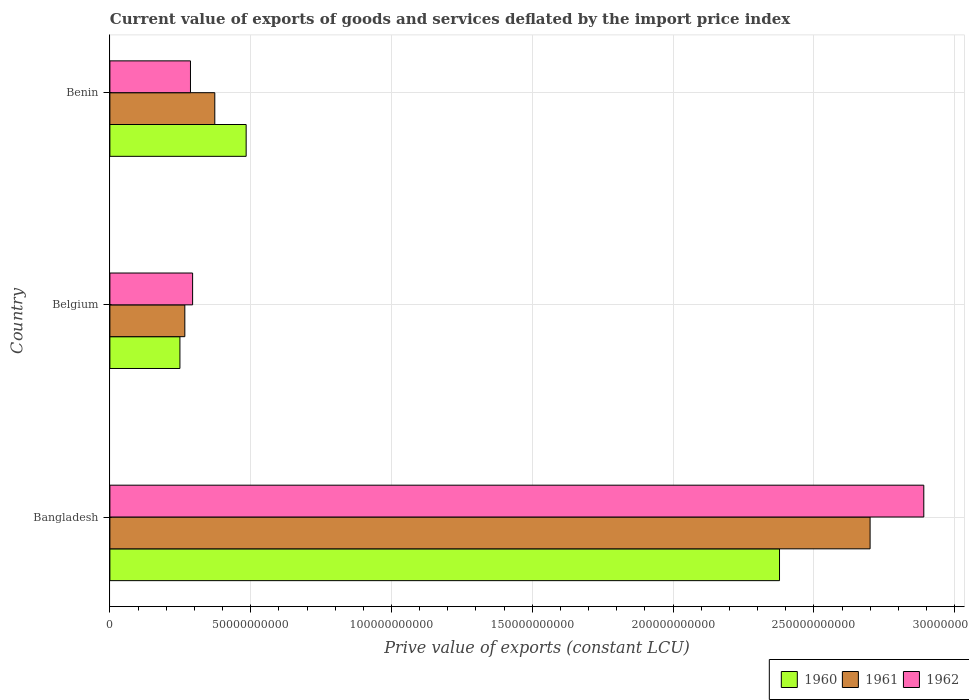How many different coloured bars are there?
Give a very brief answer. 3. How many groups of bars are there?
Your answer should be very brief. 3. Are the number of bars per tick equal to the number of legend labels?
Your answer should be compact. Yes. Are the number of bars on each tick of the Y-axis equal?
Provide a short and direct response. Yes. In how many cases, is the number of bars for a given country not equal to the number of legend labels?
Keep it short and to the point. 0. What is the prive value of exports in 1960 in Benin?
Make the answer very short. 4.84e+1. Across all countries, what is the maximum prive value of exports in 1960?
Offer a very short reply. 2.38e+11. Across all countries, what is the minimum prive value of exports in 1962?
Your response must be concise. 2.86e+1. In which country was the prive value of exports in 1962 minimum?
Offer a very short reply. Benin. What is the total prive value of exports in 1961 in the graph?
Your response must be concise. 3.34e+11. What is the difference between the prive value of exports in 1961 in Bangladesh and that in Belgium?
Provide a short and direct response. 2.43e+11. What is the difference between the prive value of exports in 1962 in Bangladesh and the prive value of exports in 1960 in Belgium?
Your answer should be compact. 2.64e+11. What is the average prive value of exports in 1961 per country?
Give a very brief answer. 1.11e+11. What is the difference between the prive value of exports in 1962 and prive value of exports in 1960 in Benin?
Make the answer very short. -1.98e+1. What is the ratio of the prive value of exports in 1960 in Belgium to that in Benin?
Provide a succinct answer. 0.51. Is the difference between the prive value of exports in 1962 in Bangladesh and Benin greater than the difference between the prive value of exports in 1960 in Bangladesh and Benin?
Your response must be concise. Yes. What is the difference between the highest and the second highest prive value of exports in 1962?
Provide a short and direct response. 2.60e+11. What is the difference between the highest and the lowest prive value of exports in 1962?
Offer a terse response. 2.60e+11. Is the sum of the prive value of exports in 1962 in Belgium and Benin greater than the maximum prive value of exports in 1960 across all countries?
Offer a very short reply. No. What does the 3rd bar from the top in Benin represents?
Ensure brevity in your answer.  1960. What does the 1st bar from the bottom in Belgium represents?
Make the answer very short. 1960. How many bars are there?
Give a very brief answer. 9. Are all the bars in the graph horizontal?
Make the answer very short. Yes. How many countries are there in the graph?
Ensure brevity in your answer.  3. Are the values on the major ticks of X-axis written in scientific E-notation?
Make the answer very short. No. Does the graph contain grids?
Ensure brevity in your answer.  Yes. How are the legend labels stacked?
Offer a very short reply. Horizontal. What is the title of the graph?
Ensure brevity in your answer.  Current value of exports of goods and services deflated by the import price index. What is the label or title of the X-axis?
Your answer should be compact. Prive value of exports (constant LCU). What is the label or title of the Y-axis?
Your response must be concise. Country. What is the Prive value of exports (constant LCU) in 1960 in Bangladesh?
Offer a very short reply. 2.38e+11. What is the Prive value of exports (constant LCU) of 1961 in Bangladesh?
Make the answer very short. 2.70e+11. What is the Prive value of exports (constant LCU) in 1962 in Bangladesh?
Your answer should be very brief. 2.89e+11. What is the Prive value of exports (constant LCU) of 1960 in Belgium?
Keep it short and to the point. 2.49e+1. What is the Prive value of exports (constant LCU) of 1961 in Belgium?
Offer a very short reply. 2.66e+1. What is the Prive value of exports (constant LCU) in 1962 in Belgium?
Ensure brevity in your answer.  2.94e+1. What is the Prive value of exports (constant LCU) of 1960 in Benin?
Keep it short and to the point. 4.84e+1. What is the Prive value of exports (constant LCU) of 1961 in Benin?
Your answer should be very brief. 3.73e+1. What is the Prive value of exports (constant LCU) of 1962 in Benin?
Provide a succinct answer. 2.86e+1. Across all countries, what is the maximum Prive value of exports (constant LCU) in 1960?
Your answer should be very brief. 2.38e+11. Across all countries, what is the maximum Prive value of exports (constant LCU) in 1961?
Your answer should be very brief. 2.70e+11. Across all countries, what is the maximum Prive value of exports (constant LCU) in 1962?
Offer a terse response. 2.89e+11. Across all countries, what is the minimum Prive value of exports (constant LCU) of 1960?
Offer a very short reply. 2.49e+1. Across all countries, what is the minimum Prive value of exports (constant LCU) of 1961?
Make the answer very short. 2.66e+1. Across all countries, what is the minimum Prive value of exports (constant LCU) in 1962?
Offer a terse response. 2.86e+1. What is the total Prive value of exports (constant LCU) in 1960 in the graph?
Offer a very short reply. 3.11e+11. What is the total Prive value of exports (constant LCU) in 1961 in the graph?
Provide a short and direct response. 3.34e+11. What is the total Prive value of exports (constant LCU) in 1962 in the graph?
Keep it short and to the point. 3.47e+11. What is the difference between the Prive value of exports (constant LCU) of 1960 in Bangladesh and that in Belgium?
Provide a short and direct response. 2.13e+11. What is the difference between the Prive value of exports (constant LCU) of 1961 in Bangladesh and that in Belgium?
Provide a short and direct response. 2.43e+11. What is the difference between the Prive value of exports (constant LCU) of 1962 in Bangladesh and that in Belgium?
Make the answer very short. 2.60e+11. What is the difference between the Prive value of exports (constant LCU) in 1960 in Bangladesh and that in Benin?
Offer a very short reply. 1.89e+11. What is the difference between the Prive value of exports (constant LCU) of 1961 in Bangladesh and that in Benin?
Make the answer very short. 2.33e+11. What is the difference between the Prive value of exports (constant LCU) in 1962 in Bangladesh and that in Benin?
Give a very brief answer. 2.60e+11. What is the difference between the Prive value of exports (constant LCU) of 1960 in Belgium and that in Benin?
Your answer should be very brief. -2.35e+1. What is the difference between the Prive value of exports (constant LCU) in 1961 in Belgium and that in Benin?
Make the answer very short. -1.06e+1. What is the difference between the Prive value of exports (constant LCU) of 1962 in Belgium and that in Benin?
Your answer should be very brief. 7.58e+08. What is the difference between the Prive value of exports (constant LCU) in 1960 in Bangladesh and the Prive value of exports (constant LCU) in 1961 in Belgium?
Your answer should be compact. 2.11e+11. What is the difference between the Prive value of exports (constant LCU) of 1960 in Bangladesh and the Prive value of exports (constant LCU) of 1962 in Belgium?
Your answer should be compact. 2.08e+11. What is the difference between the Prive value of exports (constant LCU) of 1961 in Bangladesh and the Prive value of exports (constant LCU) of 1962 in Belgium?
Your response must be concise. 2.41e+11. What is the difference between the Prive value of exports (constant LCU) in 1960 in Bangladesh and the Prive value of exports (constant LCU) in 1961 in Benin?
Provide a succinct answer. 2.01e+11. What is the difference between the Prive value of exports (constant LCU) in 1960 in Bangladesh and the Prive value of exports (constant LCU) in 1962 in Benin?
Offer a very short reply. 2.09e+11. What is the difference between the Prive value of exports (constant LCU) of 1961 in Bangladesh and the Prive value of exports (constant LCU) of 1962 in Benin?
Your response must be concise. 2.41e+11. What is the difference between the Prive value of exports (constant LCU) of 1960 in Belgium and the Prive value of exports (constant LCU) of 1961 in Benin?
Ensure brevity in your answer.  -1.24e+1. What is the difference between the Prive value of exports (constant LCU) of 1960 in Belgium and the Prive value of exports (constant LCU) of 1962 in Benin?
Ensure brevity in your answer.  -3.75e+09. What is the difference between the Prive value of exports (constant LCU) in 1961 in Belgium and the Prive value of exports (constant LCU) in 1962 in Benin?
Provide a short and direct response. -2.00e+09. What is the average Prive value of exports (constant LCU) in 1960 per country?
Your response must be concise. 1.04e+11. What is the average Prive value of exports (constant LCU) of 1961 per country?
Your response must be concise. 1.11e+11. What is the average Prive value of exports (constant LCU) of 1962 per country?
Provide a succinct answer. 1.16e+11. What is the difference between the Prive value of exports (constant LCU) of 1960 and Prive value of exports (constant LCU) of 1961 in Bangladesh?
Keep it short and to the point. -3.22e+1. What is the difference between the Prive value of exports (constant LCU) of 1960 and Prive value of exports (constant LCU) of 1962 in Bangladesh?
Provide a succinct answer. -5.12e+1. What is the difference between the Prive value of exports (constant LCU) of 1961 and Prive value of exports (constant LCU) of 1962 in Bangladesh?
Offer a terse response. -1.91e+1. What is the difference between the Prive value of exports (constant LCU) in 1960 and Prive value of exports (constant LCU) in 1961 in Belgium?
Your answer should be compact. -1.74e+09. What is the difference between the Prive value of exports (constant LCU) of 1960 and Prive value of exports (constant LCU) of 1962 in Belgium?
Your response must be concise. -4.50e+09. What is the difference between the Prive value of exports (constant LCU) of 1961 and Prive value of exports (constant LCU) of 1962 in Belgium?
Provide a succinct answer. -2.76e+09. What is the difference between the Prive value of exports (constant LCU) in 1960 and Prive value of exports (constant LCU) in 1961 in Benin?
Your answer should be compact. 1.11e+1. What is the difference between the Prive value of exports (constant LCU) of 1960 and Prive value of exports (constant LCU) of 1962 in Benin?
Your answer should be very brief. 1.98e+1. What is the difference between the Prive value of exports (constant LCU) of 1961 and Prive value of exports (constant LCU) of 1962 in Benin?
Ensure brevity in your answer.  8.64e+09. What is the ratio of the Prive value of exports (constant LCU) in 1960 in Bangladesh to that in Belgium?
Your response must be concise. 9.56. What is the ratio of the Prive value of exports (constant LCU) of 1961 in Bangladesh to that in Belgium?
Offer a very short reply. 10.14. What is the ratio of the Prive value of exports (constant LCU) of 1962 in Bangladesh to that in Belgium?
Offer a very short reply. 9.84. What is the ratio of the Prive value of exports (constant LCU) in 1960 in Bangladesh to that in Benin?
Provide a short and direct response. 4.91. What is the ratio of the Prive value of exports (constant LCU) in 1961 in Bangladesh to that in Benin?
Provide a succinct answer. 7.25. What is the ratio of the Prive value of exports (constant LCU) of 1962 in Bangladesh to that in Benin?
Your response must be concise. 10.1. What is the ratio of the Prive value of exports (constant LCU) in 1960 in Belgium to that in Benin?
Offer a terse response. 0.51. What is the ratio of the Prive value of exports (constant LCU) in 1961 in Belgium to that in Benin?
Your answer should be very brief. 0.71. What is the ratio of the Prive value of exports (constant LCU) of 1962 in Belgium to that in Benin?
Offer a very short reply. 1.03. What is the difference between the highest and the second highest Prive value of exports (constant LCU) of 1960?
Provide a succinct answer. 1.89e+11. What is the difference between the highest and the second highest Prive value of exports (constant LCU) of 1961?
Your answer should be very brief. 2.33e+11. What is the difference between the highest and the second highest Prive value of exports (constant LCU) of 1962?
Keep it short and to the point. 2.60e+11. What is the difference between the highest and the lowest Prive value of exports (constant LCU) in 1960?
Your answer should be very brief. 2.13e+11. What is the difference between the highest and the lowest Prive value of exports (constant LCU) of 1961?
Your answer should be compact. 2.43e+11. What is the difference between the highest and the lowest Prive value of exports (constant LCU) of 1962?
Make the answer very short. 2.60e+11. 